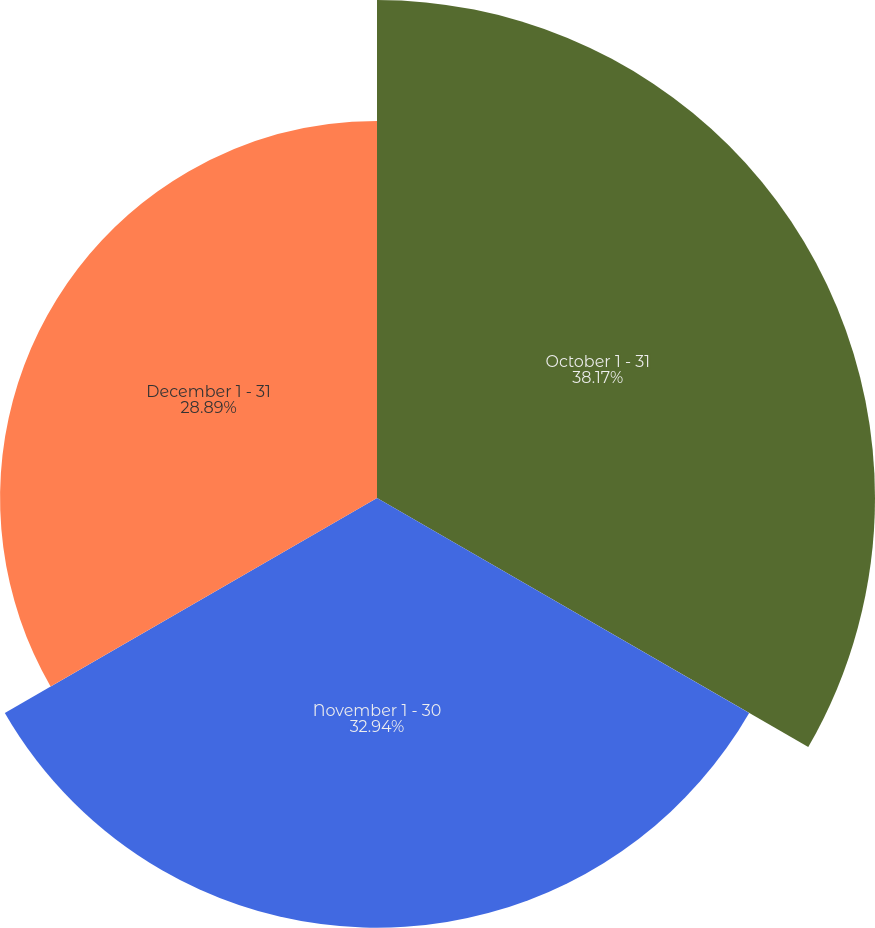Convert chart. <chart><loc_0><loc_0><loc_500><loc_500><pie_chart><fcel>October 1 - 31<fcel>November 1 - 30<fcel>December 1 - 31<nl><fcel>38.17%<fcel>32.94%<fcel>28.89%<nl></chart> 